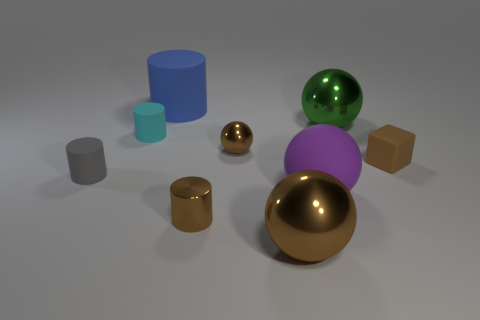Subtract all red cylinders. Subtract all yellow cubes. How many cylinders are left? 4 Subtract all cylinders. How many objects are left? 5 Subtract 1 green balls. How many objects are left? 8 Subtract all purple objects. Subtract all tiny gray things. How many objects are left? 7 Add 4 small gray rubber things. How many small gray rubber things are left? 5 Add 5 gray matte spheres. How many gray matte spheres exist? 5 